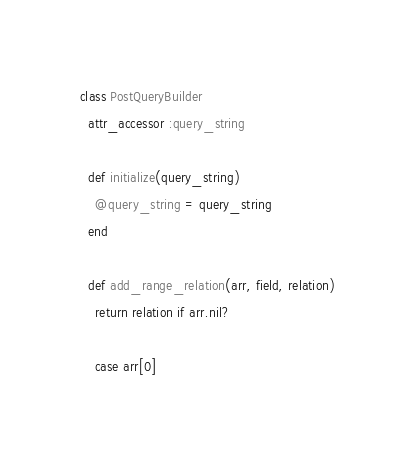Convert code to text. <code><loc_0><loc_0><loc_500><loc_500><_Ruby_>class PostQueryBuilder
  attr_accessor :query_string

  def initialize(query_string)
    @query_string = query_string
  end

  def add_range_relation(arr, field, relation)
    return relation if arr.nil?

    case arr[0]</code> 